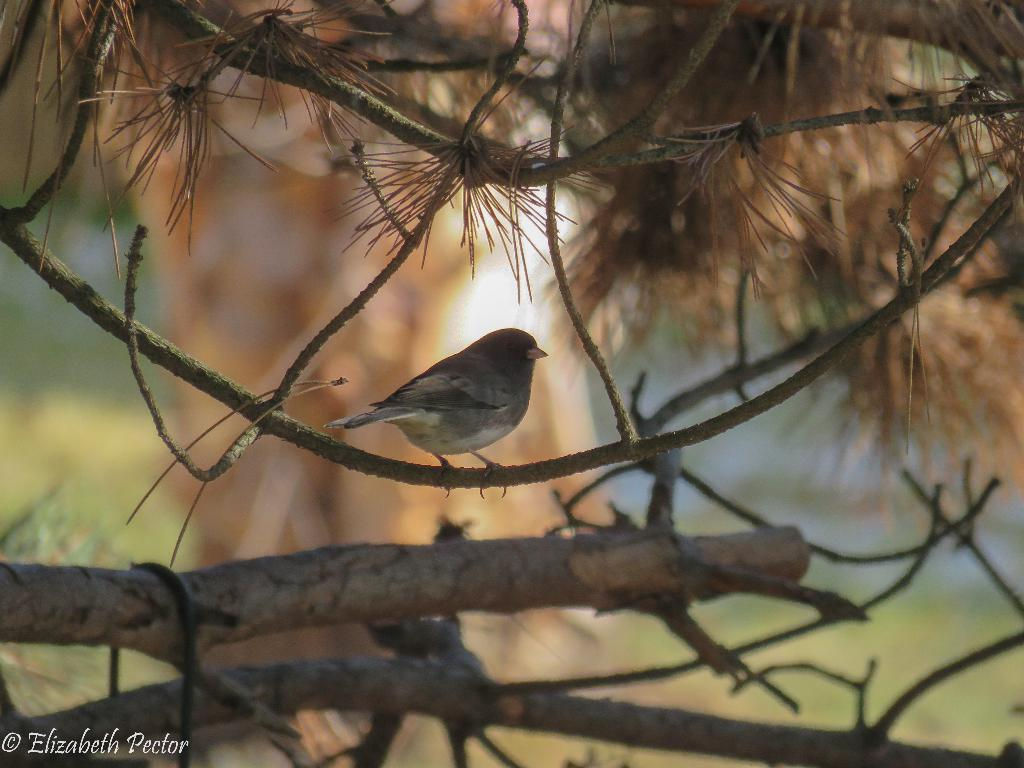Where was the image taken? The image was taken outdoors. What can be seen in the background of the image? There is a ground with grass and a tree in the background. What is the main subject of the image? There is a bird on a stem in the middle of the image. How does the bird express its feelings in the image? The image does not convey the bird's feelings, as it is a still image and not capable of expressing emotions. 